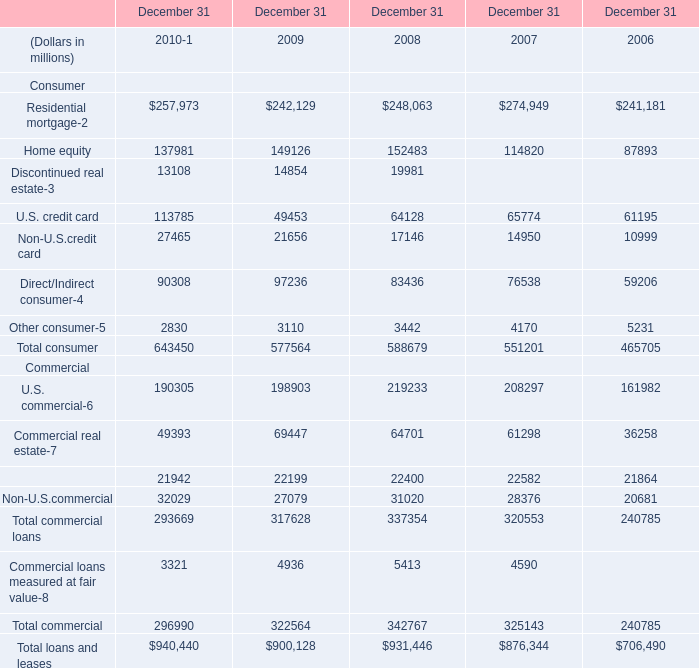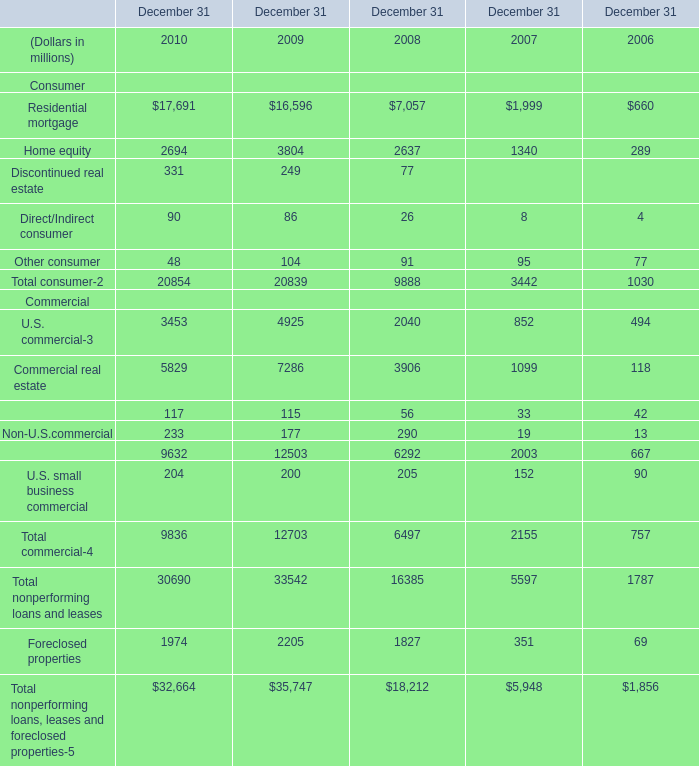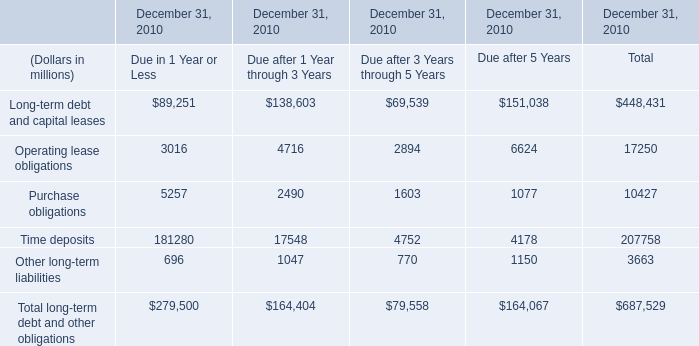What's the sum of Consumer in 2010? (in million) 
Answer: 20854. 